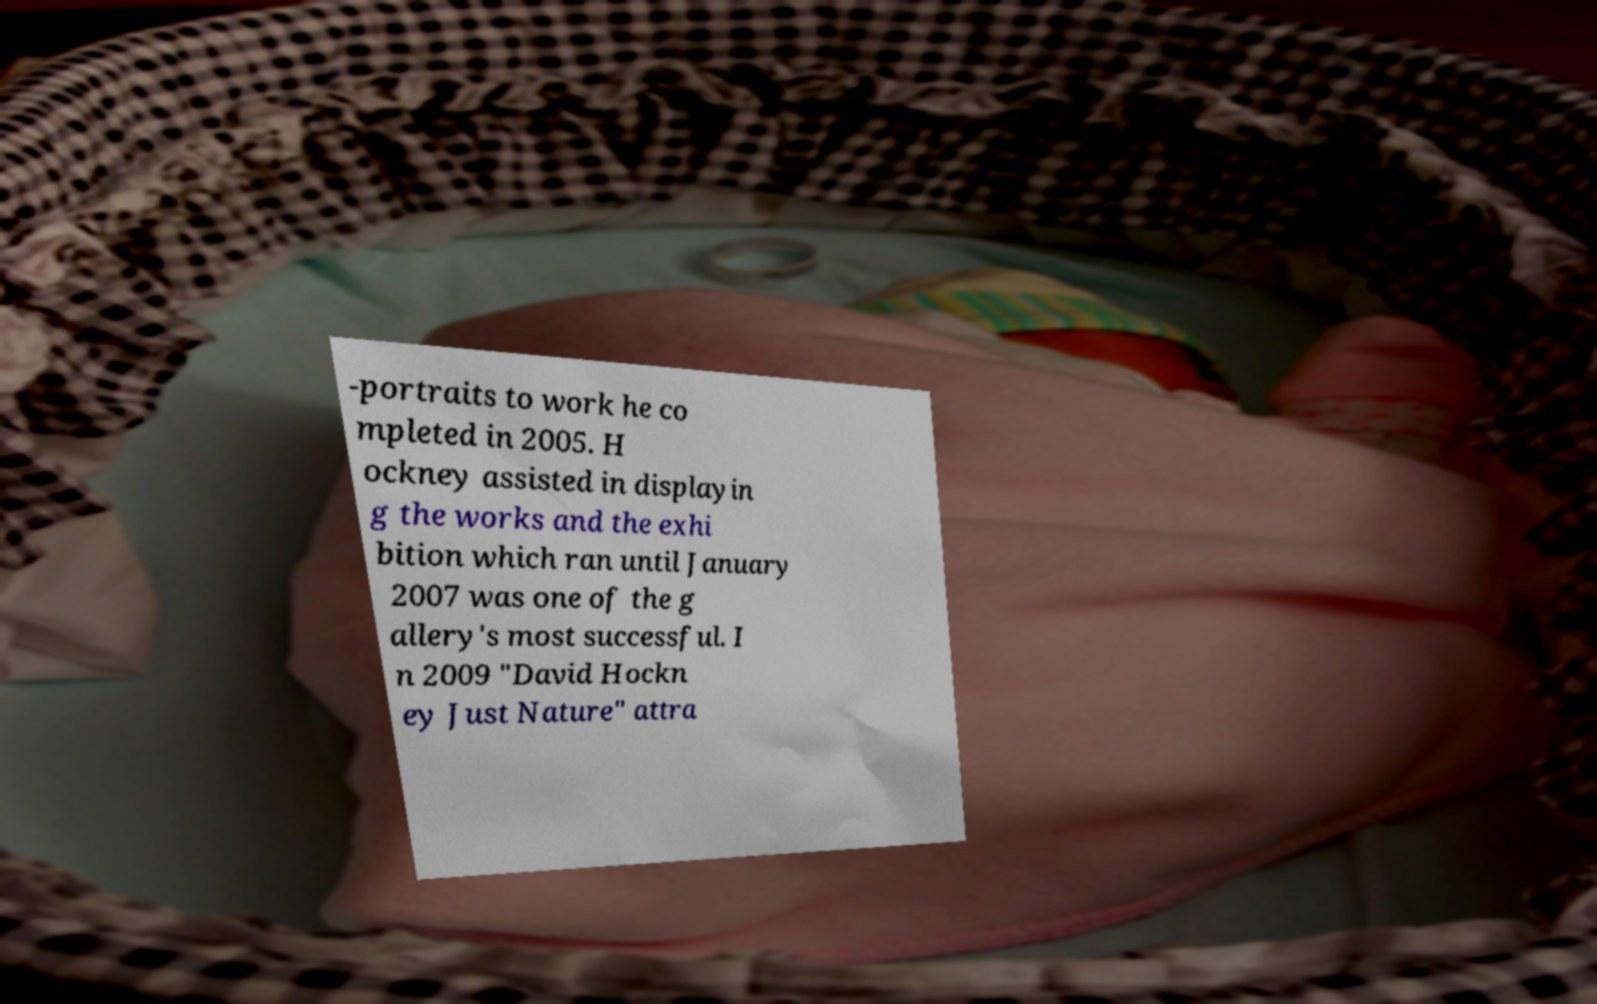For documentation purposes, I need the text within this image transcribed. Could you provide that? -portraits to work he co mpleted in 2005. H ockney assisted in displayin g the works and the exhi bition which ran until January 2007 was one of the g allery's most successful. I n 2009 "David Hockn ey Just Nature" attra 